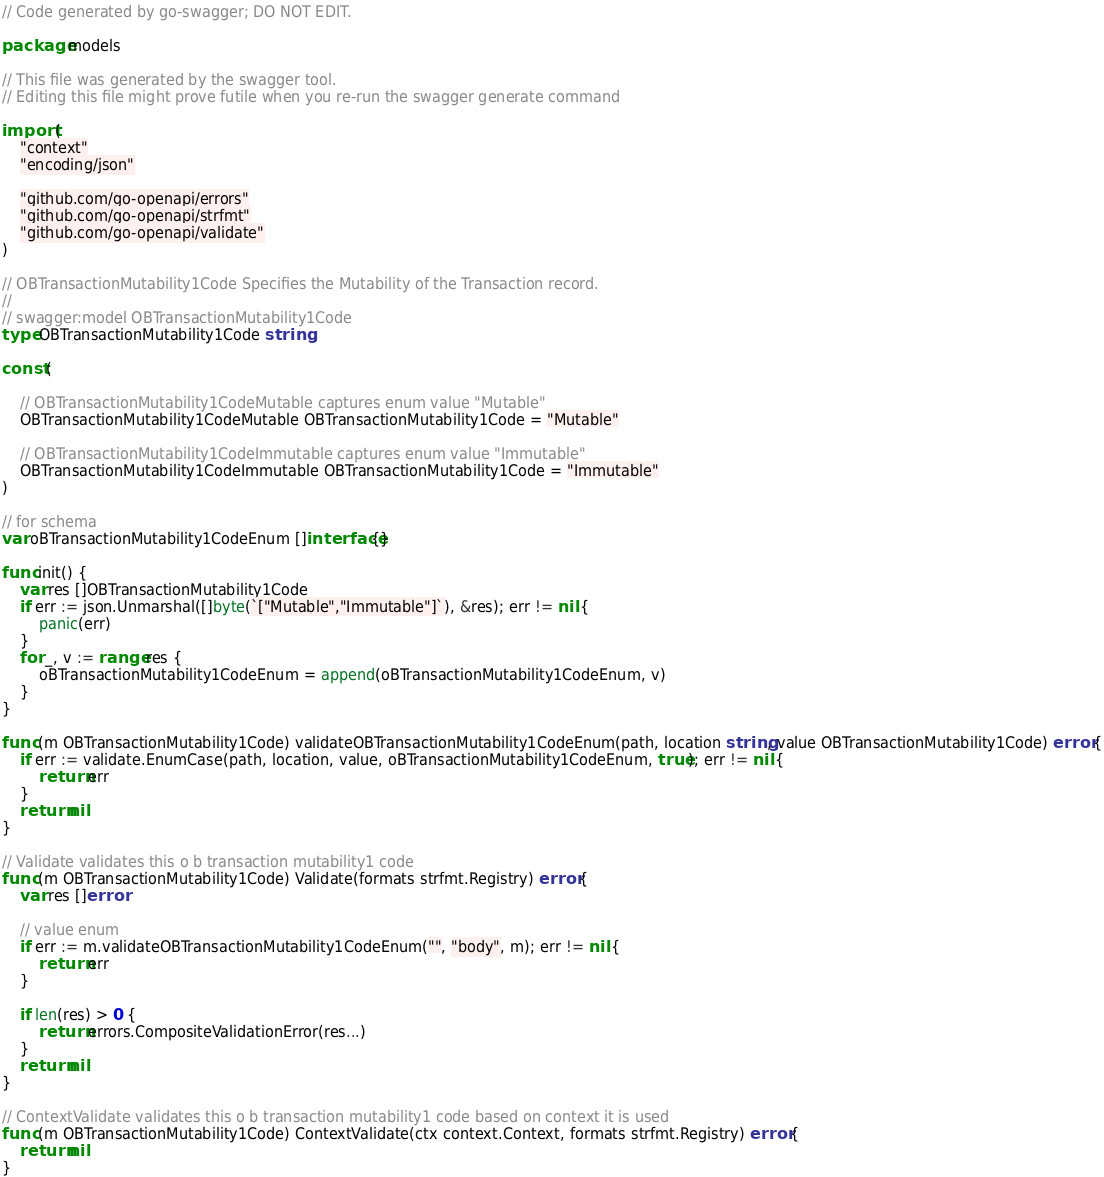<code> <loc_0><loc_0><loc_500><loc_500><_Go_>// Code generated by go-swagger; DO NOT EDIT.

package models

// This file was generated by the swagger tool.
// Editing this file might prove futile when you re-run the swagger generate command

import (
	"context"
	"encoding/json"

	"github.com/go-openapi/errors"
	"github.com/go-openapi/strfmt"
	"github.com/go-openapi/validate"
)

// OBTransactionMutability1Code Specifies the Mutability of the Transaction record.
//
// swagger:model OBTransactionMutability1Code
type OBTransactionMutability1Code string

const (

	// OBTransactionMutability1CodeMutable captures enum value "Mutable"
	OBTransactionMutability1CodeMutable OBTransactionMutability1Code = "Mutable"

	// OBTransactionMutability1CodeImmutable captures enum value "Immutable"
	OBTransactionMutability1CodeImmutable OBTransactionMutability1Code = "Immutable"
)

// for schema
var oBTransactionMutability1CodeEnum []interface{}

func init() {
	var res []OBTransactionMutability1Code
	if err := json.Unmarshal([]byte(`["Mutable","Immutable"]`), &res); err != nil {
		panic(err)
	}
	for _, v := range res {
		oBTransactionMutability1CodeEnum = append(oBTransactionMutability1CodeEnum, v)
	}
}

func (m OBTransactionMutability1Code) validateOBTransactionMutability1CodeEnum(path, location string, value OBTransactionMutability1Code) error {
	if err := validate.EnumCase(path, location, value, oBTransactionMutability1CodeEnum, true); err != nil {
		return err
	}
	return nil
}

// Validate validates this o b transaction mutability1 code
func (m OBTransactionMutability1Code) Validate(formats strfmt.Registry) error {
	var res []error

	// value enum
	if err := m.validateOBTransactionMutability1CodeEnum("", "body", m); err != nil {
		return err
	}

	if len(res) > 0 {
		return errors.CompositeValidationError(res...)
	}
	return nil
}

// ContextValidate validates this o b transaction mutability1 code based on context it is used
func (m OBTransactionMutability1Code) ContextValidate(ctx context.Context, formats strfmt.Registry) error {
	return nil
}
</code> 